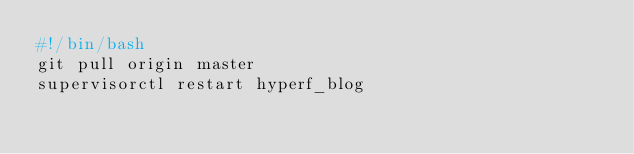Convert code to text. <code><loc_0><loc_0><loc_500><loc_500><_Bash_>#!/bin/bash
git pull origin master
supervisorctl restart hyperf_blog
</code> 